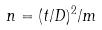Convert formula to latex. <formula><loc_0><loc_0><loc_500><loc_500>n = ( t / D ) ^ { 2 } / m</formula> 